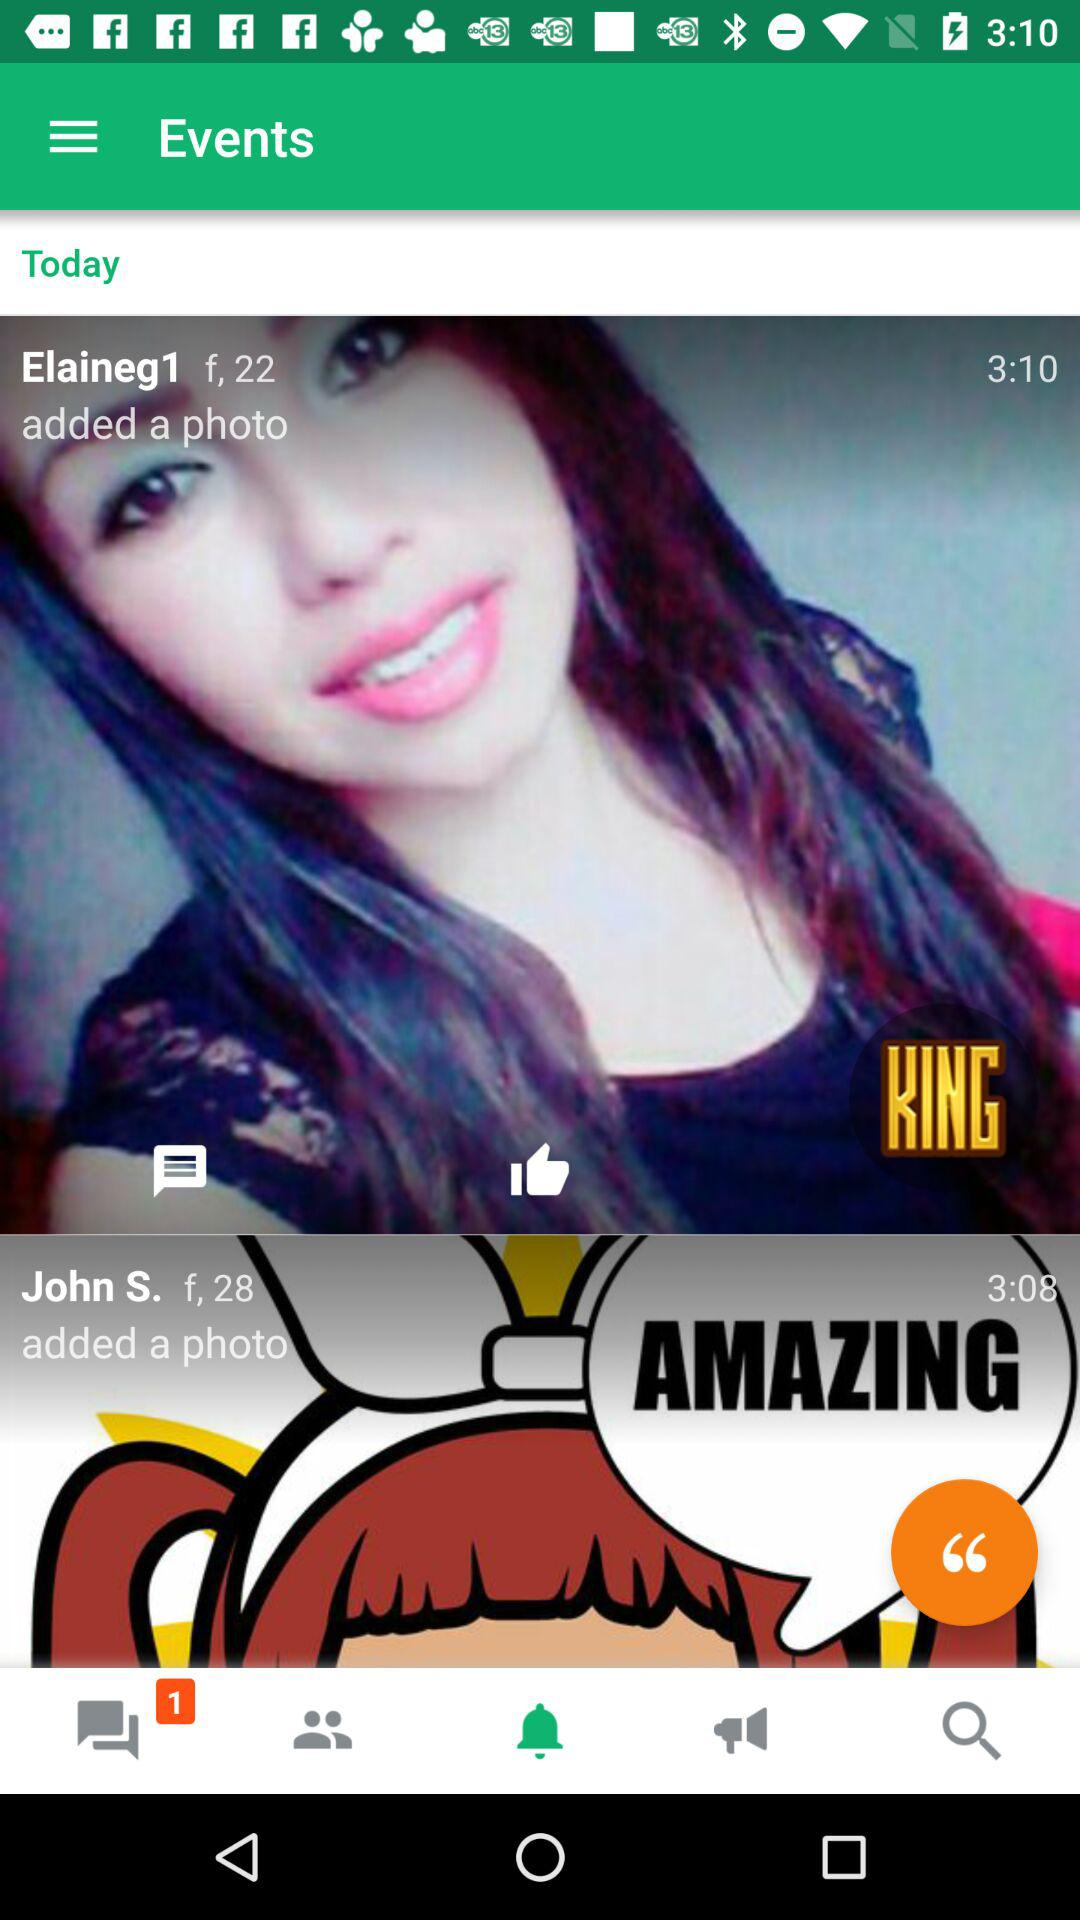What is the age of "Elaineg1"? The age of "Elaineg1" is 22. 